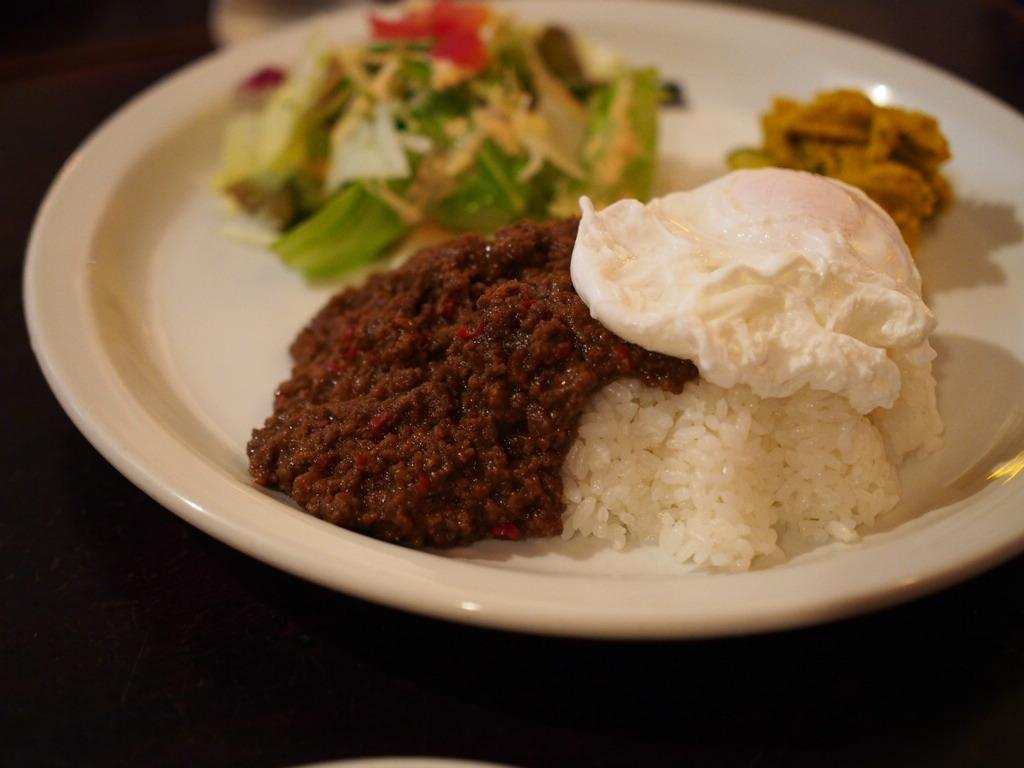What is the main subject of the image? The main subject of the image is food. How is the food presented in the image? The food is on a white plate. What colors can be seen in the food? The food has various colors, including brown, white, green, orange, and red. What is the color of the background in the image? The background of the image is black. Can you see a cannon in the image? No, there is no cannon present in the image. How many stars are visible in the image? There are no stars visible in the image; it features food on a white plate against a black background. 